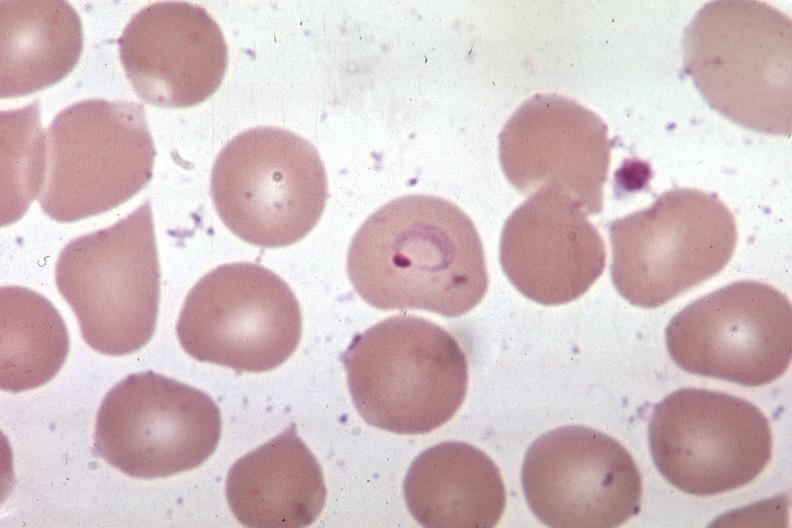what is present?
Answer the question using a single word or phrase. Hematologic 